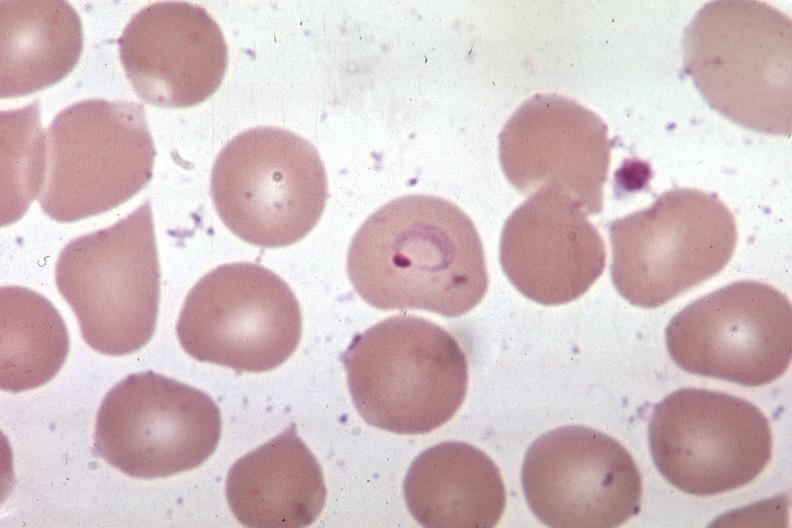what is present?
Answer the question using a single word or phrase. Hematologic 